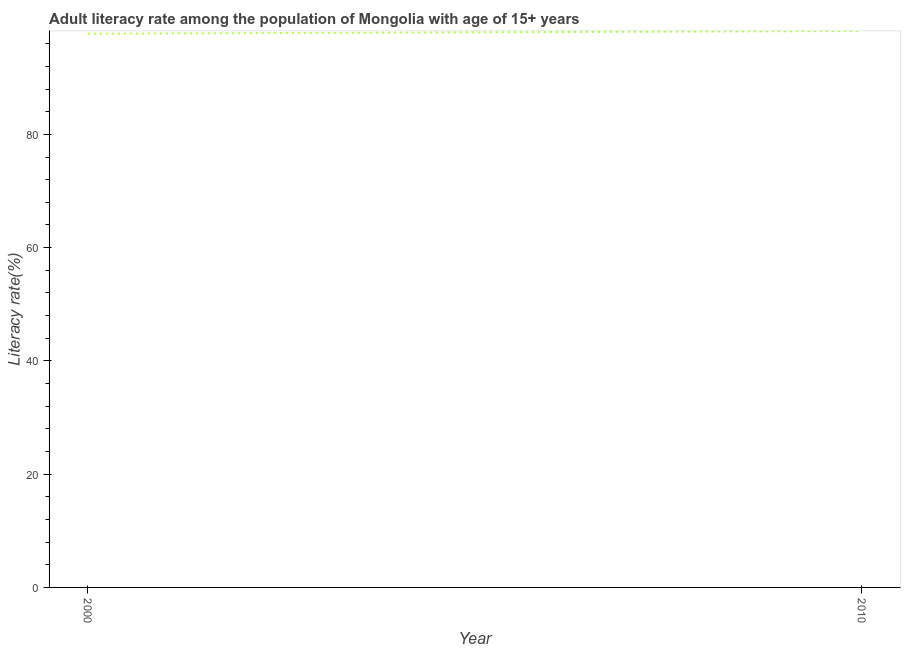What is the adult literacy rate in 2010?
Your response must be concise. 98.26. Across all years, what is the maximum adult literacy rate?
Offer a terse response. 98.26. Across all years, what is the minimum adult literacy rate?
Your response must be concise. 97.77. In which year was the adult literacy rate maximum?
Make the answer very short. 2010. In which year was the adult literacy rate minimum?
Your answer should be very brief. 2000. What is the sum of the adult literacy rate?
Make the answer very short. 196.03. What is the difference between the adult literacy rate in 2000 and 2010?
Give a very brief answer. -0.49. What is the average adult literacy rate per year?
Offer a very short reply. 98.01. What is the median adult literacy rate?
Your response must be concise. 98.01. What is the ratio of the adult literacy rate in 2000 to that in 2010?
Your response must be concise. 1. Is the adult literacy rate in 2000 less than that in 2010?
Keep it short and to the point. Yes. In how many years, is the adult literacy rate greater than the average adult literacy rate taken over all years?
Give a very brief answer. 1. How many lines are there?
Provide a succinct answer. 1. Does the graph contain grids?
Provide a short and direct response. No. What is the title of the graph?
Provide a succinct answer. Adult literacy rate among the population of Mongolia with age of 15+ years. What is the label or title of the Y-axis?
Make the answer very short. Literacy rate(%). What is the Literacy rate(%) of 2000?
Keep it short and to the point. 97.77. What is the Literacy rate(%) of 2010?
Your answer should be very brief. 98.26. What is the difference between the Literacy rate(%) in 2000 and 2010?
Keep it short and to the point. -0.49. What is the ratio of the Literacy rate(%) in 2000 to that in 2010?
Ensure brevity in your answer.  0.99. 